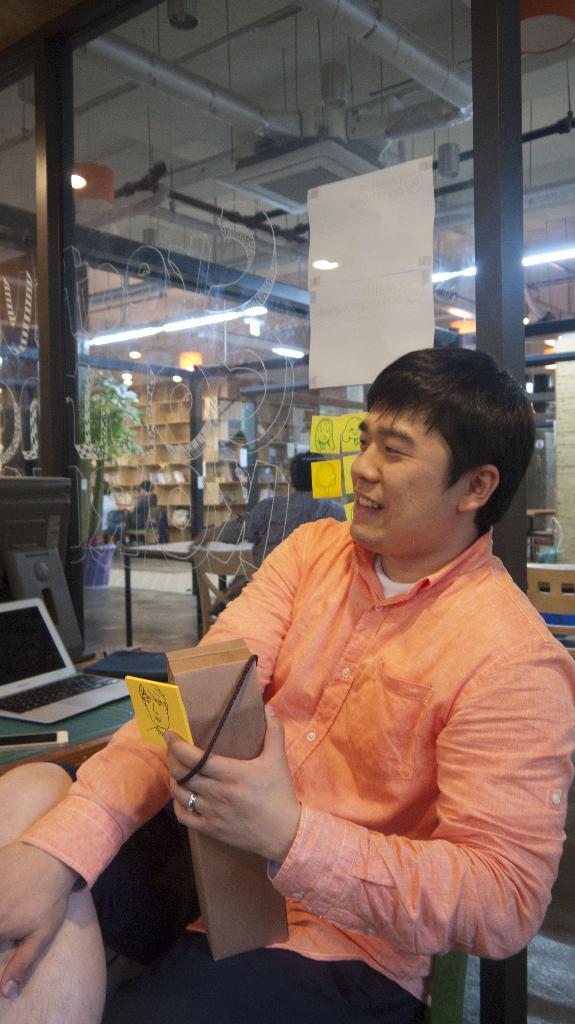Can you describe this image briefly? In this image we can see a person sitting and the person is holding objects. Behind the person there is a glass, table and a person. On the glass we can see stickers and a poster. In the background, we can see two persons sitting on chairs and few objects on the racks. On the left side, we can see a laptop on a table. At the top we can see a roof and AC vent. 